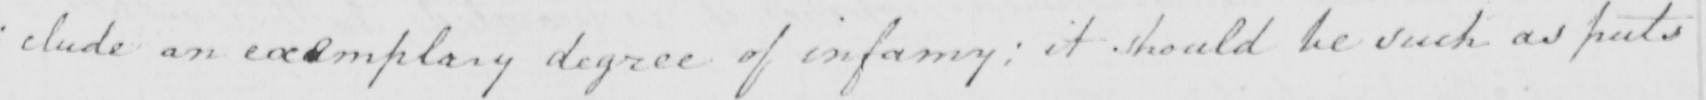What text is written in this handwritten line? : clude an exemplary degree of infamy ; it should be such as puts 